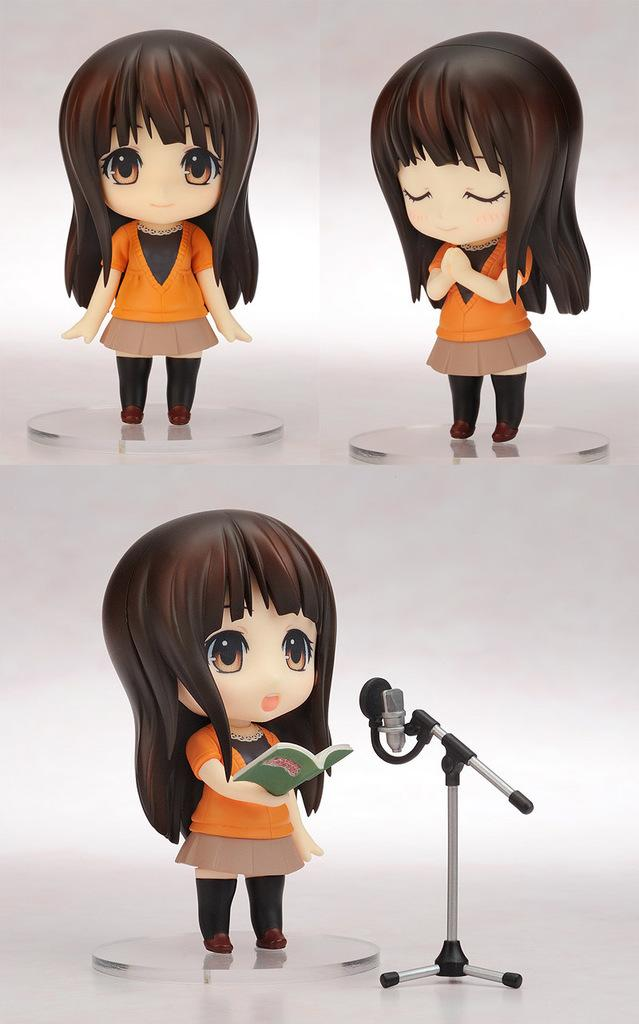What is the main subject of the image? The main subject of the image is a doll of a girl. How is the image composed? The image is a collage. What equipment is visible in the image? There is a tripod and a microphone present on the tripod. What is the doll holding in the image? The doll is holding a book in the image. Can you see a monkey interacting with the doll in the image? No, there is no monkey present in the image. What type of connection is established between the doll and the microphone in the image? There is no direct connection between the doll and the microphone in the image; they are separate objects. 